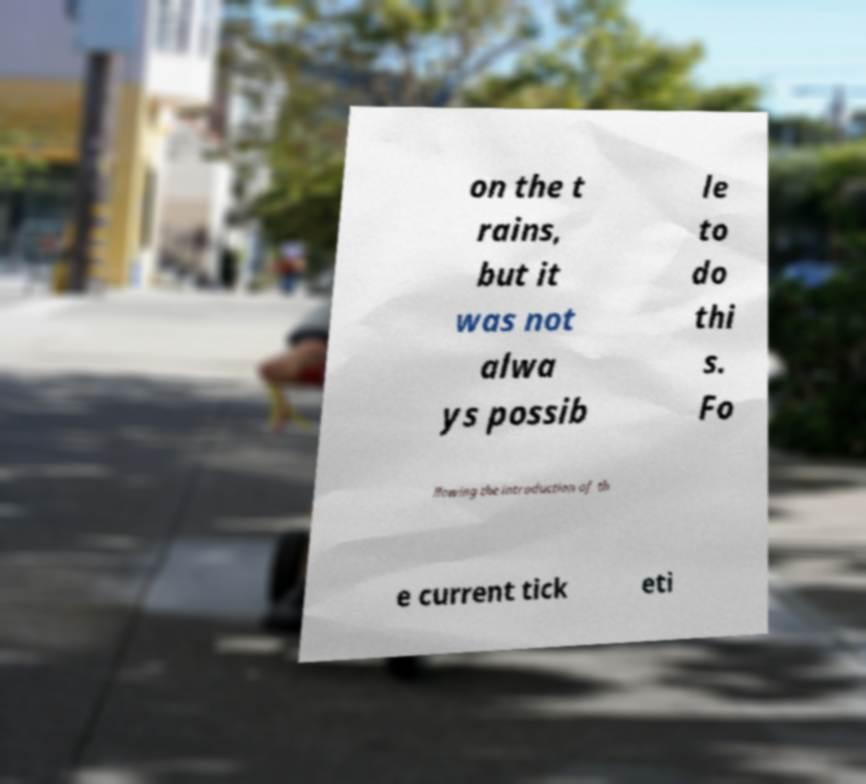Please identify and transcribe the text found in this image. on the t rains, but it was not alwa ys possib le to do thi s. Fo llowing the introduction of th e current tick eti 